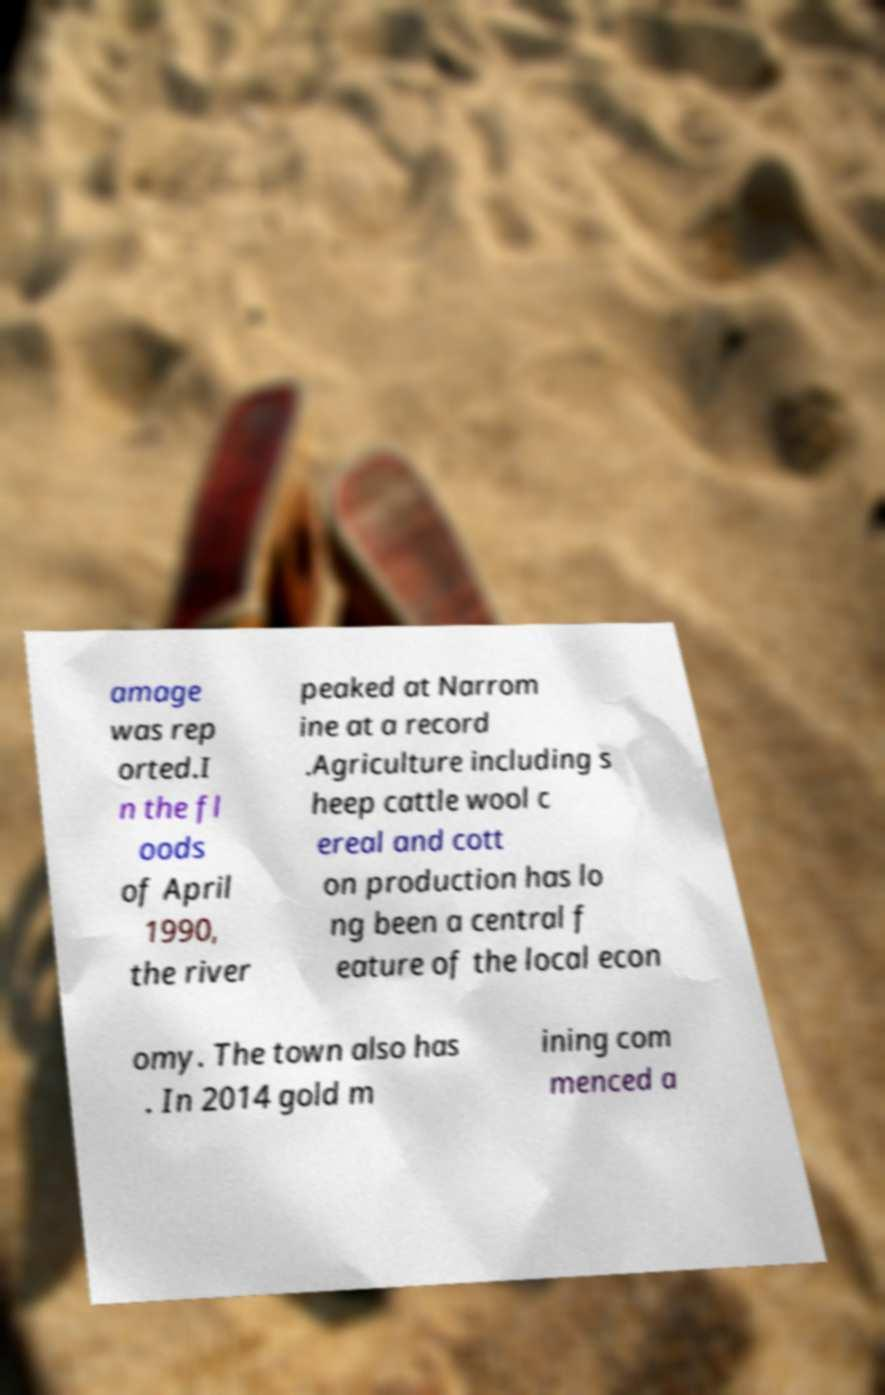Can you read and provide the text displayed in the image?This photo seems to have some interesting text. Can you extract and type it out for me? amage was rep orted.I n the fl oods of April 1990, the river peaked at Narrom ine at a record .Agriculture including s heep cattle wool c ereal and cott on production has lo ng been a central f eature of the local econ omy. The town also has . In 2014 gold m ining com menced a 